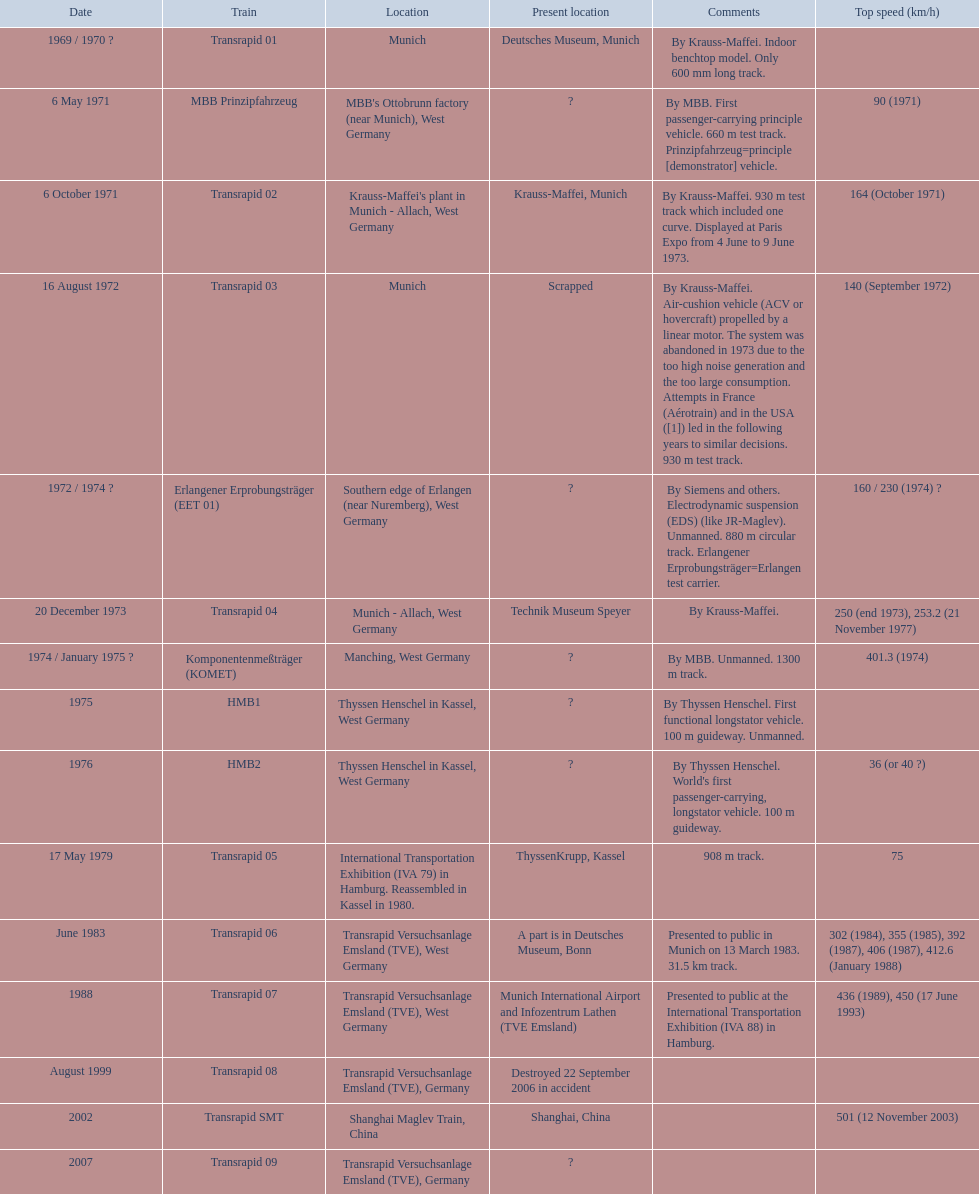Which trains have their highest speed mentioned? MBB Prinzipfahrzeug, Transrapid 02, Transrapid 03, Erlangener Erprobungsträger (EET 01), Transrapid 04, Komponentenmeßträger (KOMET), HMB2, Transrapid 05, Transrapid 06, Transrapid 07, Transrapid SMT. Which of them have munich as a location? MBB Prinzipfahrzeug, Transrapid 02, Transrapid 03. Among these, which ones have a known current location? Transrapid 02, Transrapid 03. Finally, which of these are no longer functioning? Transrapid 03. 